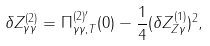<formula> <loc_0><loc_0><loc_500><loc_500>\delta Z _ { \gamma \gamma } ^ { ( 2 ) } = \Pi _ { \gamma \gamma , T } ^ { ( 2 ) ^ { \prime } } ( 0 ) - \frac { 1 } { 4 } ( \delta Z _ { Z \gamma } ^ { ( 1 ) } ) ^ { 2 } ,</formula> 